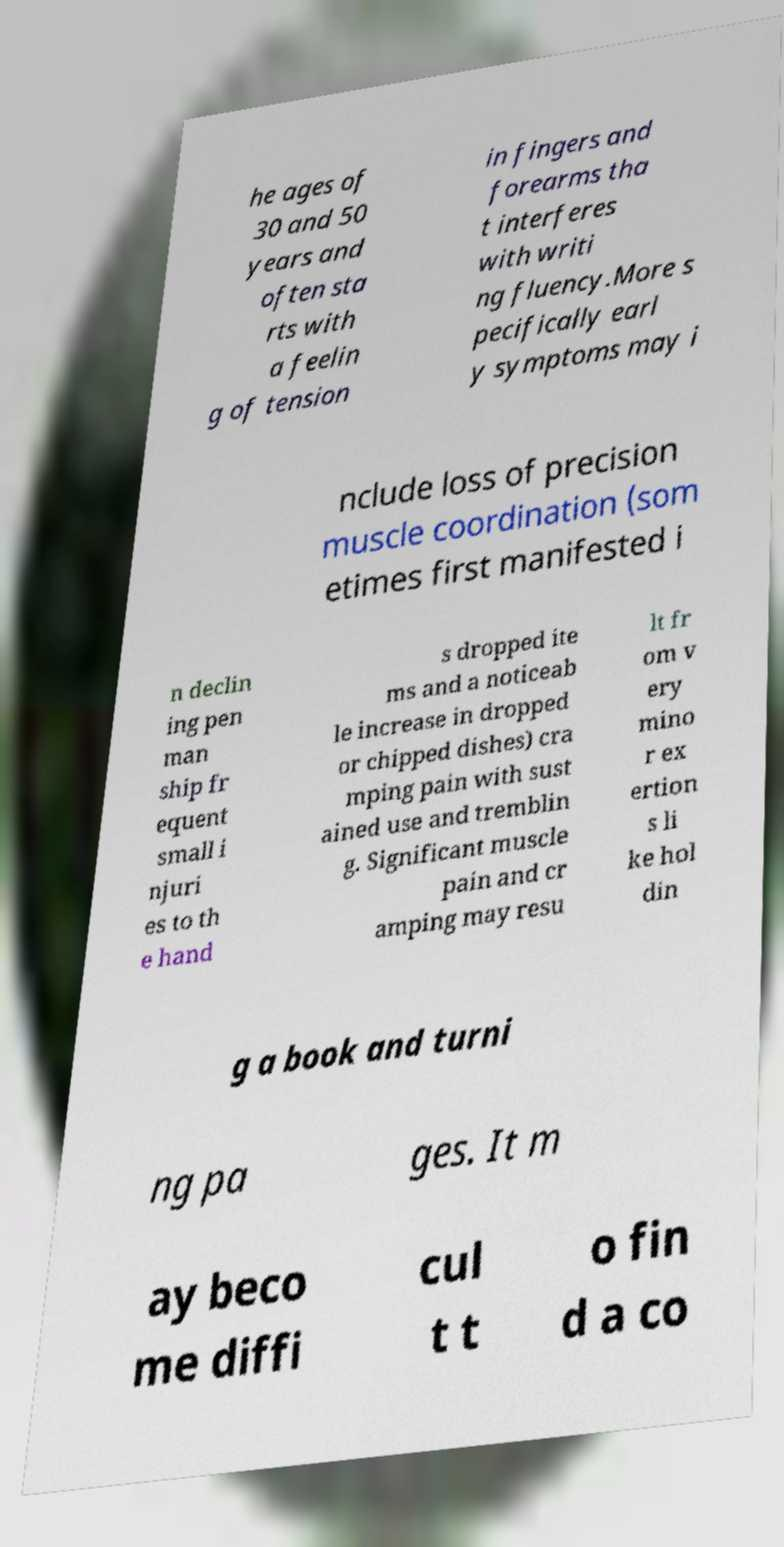Could you extract and type out the text from this image? he ages of 30 and 50 years and often sta rts with a feelin g of tension in fingers and forearms tha t interferes with writi ng fluency.More s pecifically earl y symptoms may i nclude loss of precision muscle coordination (som etimes first manifested i n declin ing pen man ship fr equent small i njuri es to th e hand s dropped ite ms and a noticeab le increase in dropped or chipped dishes) cra mping pain with sust ained use and tremblin g. Significant muscle pain and cr amping may resu lt fr om v ery mino r ex ertion s li ke hol din g a book and turni ng pa ges. It m ay beco me diffi cul t t o fin d a co 